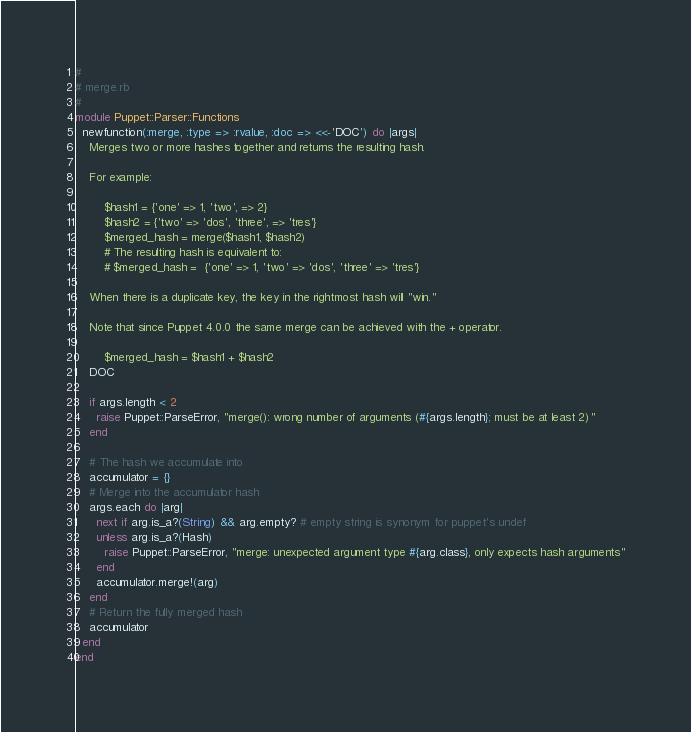Convert code to text. <code><loc_0><loc_0><loc_500><loc_500><_Ruby_>#
# merge.rb
#
module Puppet::Parser::Functions
  newfunction(:merge, :type => :rvalue, :doc => <<-'DOC') do |args|
    Merges two or more hashes together and returns the resulting hash.

    For example:

        $hash1 = {'one' => 1, 'two', => 2}
        $hash2 = {'two' => 'dos', 'three', => 'tres'}
        $merged_hash = merge($hash1, $hash2)
        # The resulting hash is equivalent to:
        # $merged_hash =  {'one' => 1, 'two' => 'dos', 'three' => 'tres'}

    When there is a duplicate key, the key in the rightmost hash will "win."

    Note that since Puppet 4.0.0 the same merge can be achieved with the + operator.

        $merged_hash = $hash1 + $hash2
    DOC

    if args.length < 2
      raise Puppet::ParseError, "merge(): wrong number of arguments (#{args.length}; must be at least 2)"
    end

    # The hash we accumulate into
    accumulator = {}
    # Merge into the accumulator hash
    args.each do |arg|
      next if arg.is_a?(String) && arg.empty? # empty string is synonym for puppet's undef
      unless arg.is_a?(Hash)
        raise Puppet::ParseError, "merge: unexpected argument type #{arg.class}, only expects hash arguments"
      end
      accumulator.merge!(arg)
    end
    # Return the fully merged hash
    accumulator
  end
end
</code> 